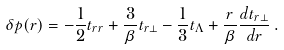Convert formula to latex. <formula><loc_0><loc_0><loc_500><loc_500>\delta p ( r ) = - \frac { 1 } { 2 } t _ { r r } + \frac { 3 } { \beta } t _ { r \perp } - \frac { 1 } { 3 } t _ { \Lambda } + \frac { r } { \beta } \frac { d t _ { r \perp } } { d r } \, .</formula> 